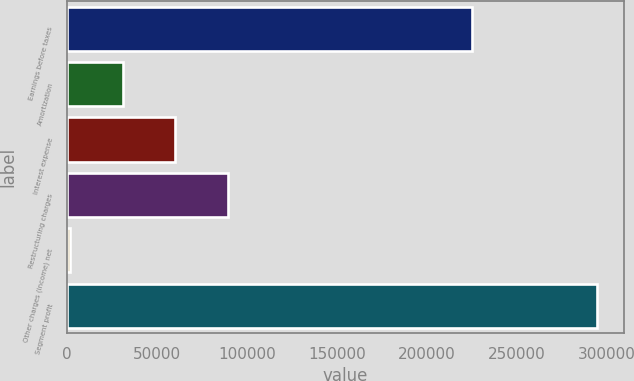Convert chart. <chart><loc_0><loc_0><loc_500><loc_500><bar_chart><fcel>Earnings before taxes<fcel>Amortization<fcel>Interest expense<fcel>Restructuring charges<fcel>Other charges (income) net<fcel>Segment profit<nl><fcel>224762<fcel>30693.1<fcel>60002.2<fcel>89311.3<fcel>1384<fcel>294475<nl></chart> 